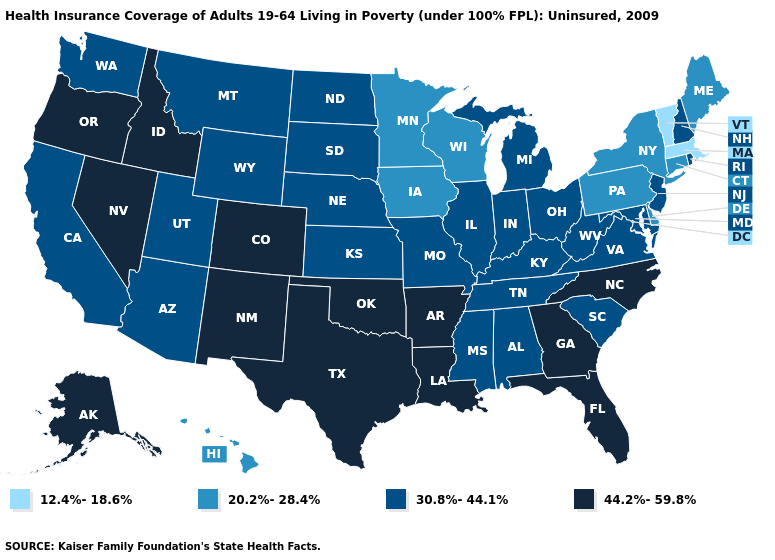Does the first symbol in the legend represent the smallest category?
Write a very short answer. Yes. Which states have the lowest value in the USA?
Quick response, please. Massachusetts, Vermont. What is the value of New Jersey?
Give a very brief answer. 30.8%-44.1%. Name the states that have a value in the range 30.8%-44.1%?
Short answer required. Alabama, Arizona, California, Illinois, Indiana, Kansas, Kentucky, Maryland, Michigan, Mississippi, Missouri, Montana, Nebraska, New Hampshire, New Jersey, North Dakota, Ohio, Rhode Island, South Carolina, South Dakota, Tennessee, Utah, Virginia, Washington, West Virginia, Wyoming. Which states hav the highest value in the MidWest?
Quick response, please. Illinois, Indiana, Kansas, Michigan, Missouri, Nebraska, North Dakota, Ohio, South Dakota. What is the value of Hawaii?
Short answer required. 20.2%-28.4%. Which states have the highest value in the USA?
Keep it brief. Alaska, Arkansas, Colorado, Florida, Georgia, Idaho, Louisiana, Nevada, New Mexico, North Carolina, Oklahoma, Oregon, Texas. Among the states that border Wyoming , which have the lowest value?
Keep it brief. Montana, Nebraska, South Dakota, Utah. Which states have the lowest value in the West?
Quick response, please. Hawaii. Does Utah have the highest value in the USA?
Be succinct. No. Which states have the highest value in the USA?
Write a very short answer. Alaska, Arkansas, Colorado, Florida, Georgia, Idaho, Louisiana, Nevada, New Mexico, North Carolina, Oklahoma, Oregon, Texas. What is the value of North Dakota?
Answer briefly. 30.8%-44.1%. Does Wisconsin have the same value as Iowa?
Keep it brief. Yes. Does the first symbol in the legend represent the smallest category?
Short answer required. Yes. Does the map have missing data?
Write a very short answer. No. 